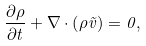Convert formula to latex. <formula><loc_0><loc_0><loc_500><loc_500>\frac { \partial \rho } { \partial t } + \nabla \cdot \left ( \rho \vec { v } \right ) = 0 ,</formula> 